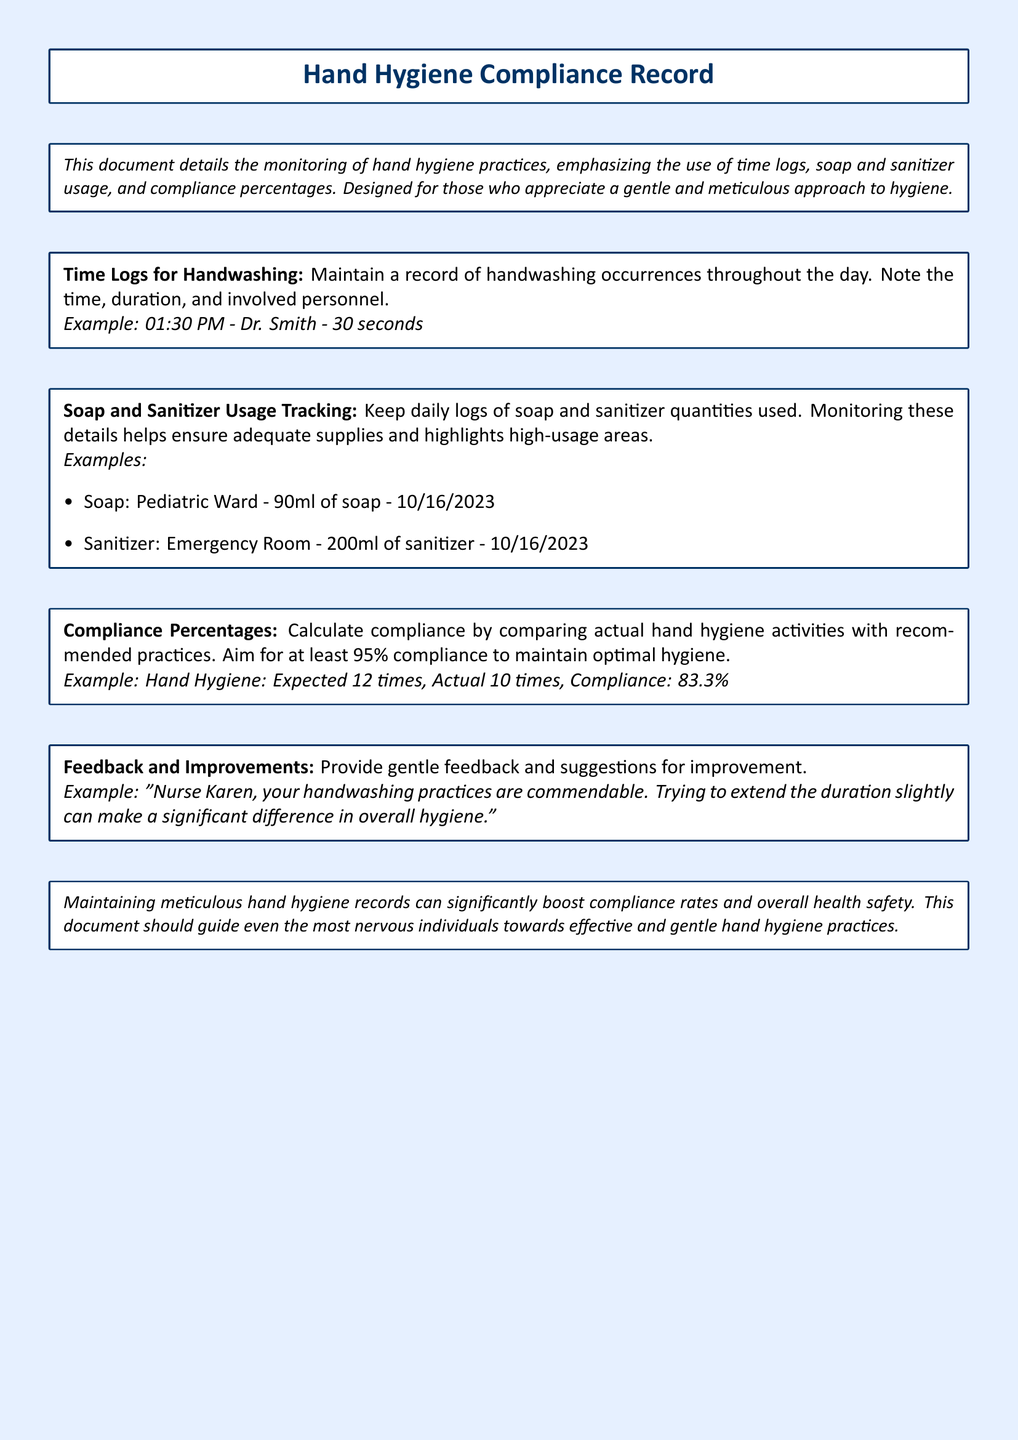What is the title of the document? The title of the document is presented prominently at the top, which is "Hand Hygiene Compliance Record."
Answer: Hand Hygiene Compliance Record What is the minimum compliance percentage aimed for? The document states that the aim for compliance is at least 95%.
Answer: 95% What example is given for a time log? An example of a time log is provided: "01:30 PM - Dr. Smith - 30 seconds."
Answer: 01:30 PM - Dr. Smith - 30 seconds What area used 90ml of soap? The document provides an example indicating that the Pediatric Ward used 90ml of soap.
Answer: Pediatric Ward What feedback is suggested for Nurse Karen? The feedback for Nurse Karen suggests extending the duration of handwashing slightly.
Answer: Extend the duration slightly What is tracked in soap and sanitizer usage? The document mentions tracking daily logs of soap and sanitizer quantities used.
Answer: Daily logs of soap and sanitizer quantities What is the expected number of hand hygiene practices? An example shows the expected number of hand hygiene practices is 12 times.
Answer: 12 times What is the compliance percentage calculated from 10 actual times? The compliance percentage is calculated as 83.3% based on the example provided.
Answer: 83.3% 